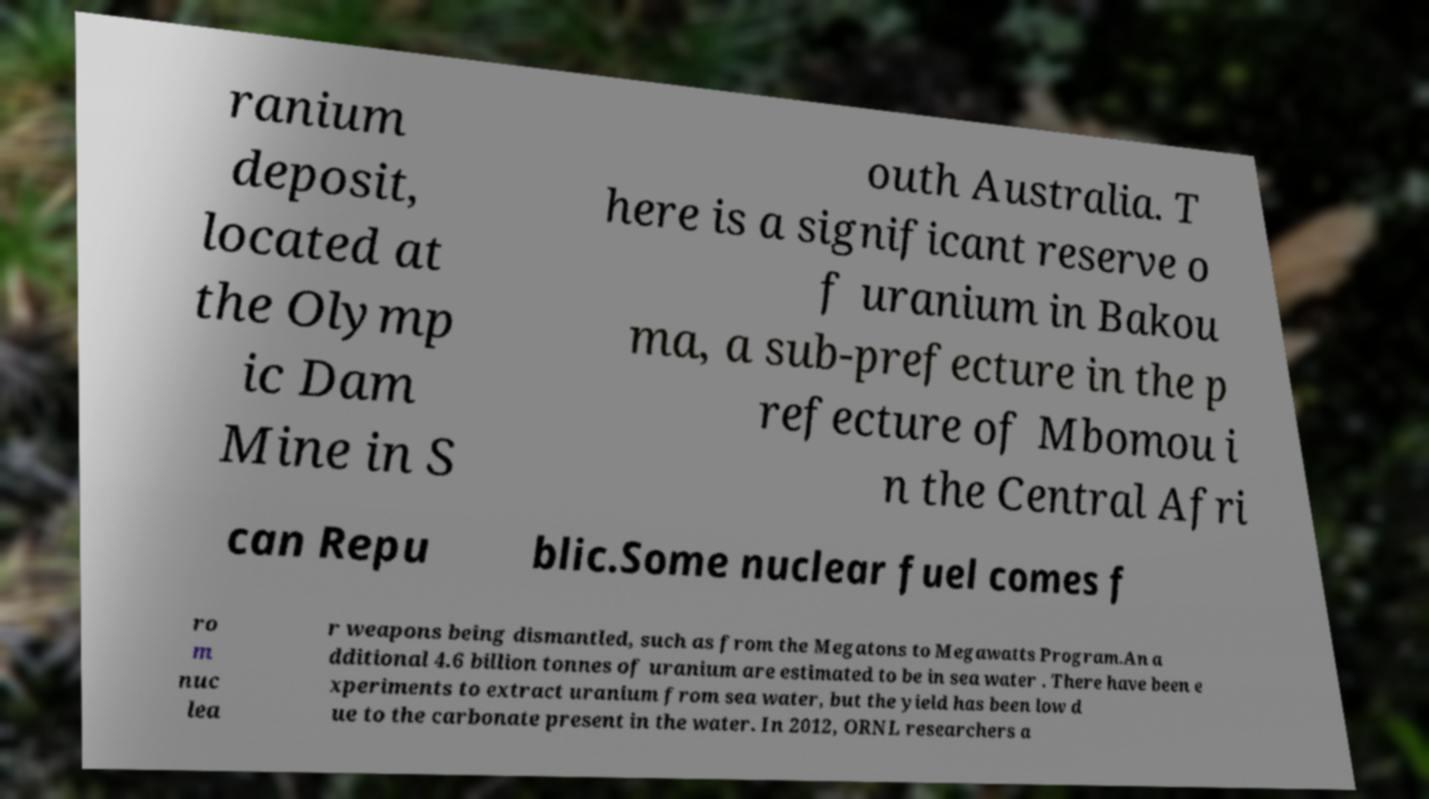Please read and relay the text visible in this image. What does it say? ranium deposit, located at the Olymp ic Dam Mine in S outh Australia. T here is a significant reserve o f uranium in Bakou ma, a sub-prefecture in the p refecture of Mbomou i n the Central Afri can Repu blic.Some nuclear fuel comes f ro m nuc lea r weapons being dismantled, such as from the Megatons to Megawatts Program.An a dditional 4.6 billion tonnes of uranium are estimated to be in sea water . There have been e xperiments to extract uranium from sea water, but the yield has been low d ue to the carbonate present in the water. In 2012, ORNL researchers a 